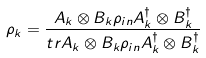Convert formula to latex. <formula><loc_0><loc_0><loc_500><loc_500>\rho _ { k } = \frac { A _ { k } \otimes B _ { k } \rho _ { i n } A _ { k } ^ { \dagger } \otimes B _ { k } ^ { \dagger } } { t r A _ { k } \otimes B _ { k } \rho _ { i n } A _ { k } ^ { \dagger } \otimes B _ { k } ^ { \dagger } }</formula> 